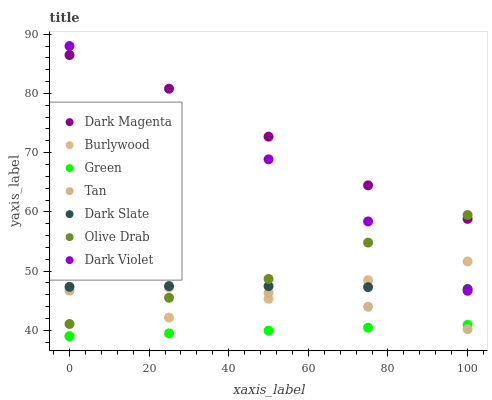Does Green have the minimum area under the curve?
Answer yes or no. Yes. Does Dark Magenta have the maximum area under the curve?
Answer yes or no. Yes. Does Burlywood have the minimum area under the curve?
Answer yes or no. No. Does Burlywood have the maximum area under the curve?
Answer yes or no. No. Is Burlywood the smoothest?
Answer yes or no. Yes. Is Dark Violet the roughest?
Answer yes or no. Yes. Is Dark Violet the smoothest?
Answer yes or no. No. Is Burlywood the roughest?
Answer yes or no. No. Does Burlywood have the lowest value?
Answer yes or no. Yes. Does Dark Violet have the lowest value?
Answer yes or no. No. Does Dark Violet have the highest value?
Answer yes or no. Yes. Does Burlywood have the highest value?
Answer yes or no. No. Is Burlywood less than Olive Drab?
Answer yes or no. Yes. Is Dark Violet greater than Green?
Answer yes or no. Yes. Does Tan intersect Green?
Answer yes or no. Yes. Is Tan less than Green?
Answer yes or no. No. Is Tan greater than Green?
Answer yes or no. No. Does Burlywood intersect Olive Drab?
Answer yes or no. No. 